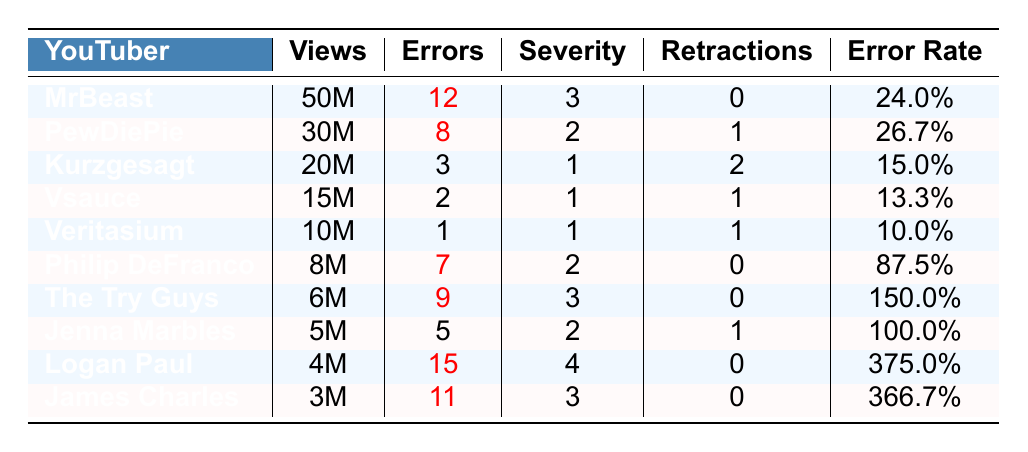What is the highest number of factual errors reported among these YouTubers? In the table, Logan Paul has the highest number of factual errors with 15.
Answer: 15 Which YouTuber has the most retractions issued? PewDiePie has issued 1 retraction, which is the highest among the listed YouTubers since the others have either 0 or 2.
Answer: 1 Calculate the total number of factual errors reported by all YouTubers. The total factual errors are obtained by summing up all values: 12 + 8 + 3 + 2 + 1 + 7 + 9 + 5 + 15 + 11 = 73.
Answer: 73 What is the average number of views per YouTuber in millions? To find the average, add the views (50M + 30M + 20M + 15M + 10M + 8M + 6M + 5M + 4M + 3M = 151M) and divide by the number of YouTubers (10): 151M / 10 = 15.1M.
Answer: 15.1M Is the error rate for The Try Guys higher than that for Philip DeFranco? The Try Guys have an error rate of 150.0%, while Philip DeFranco has an error rate of 87.5%. Since 150.0% is greater than 87.5%, the statement is true.
Answer: Yes Which YouTuber has the lowest error severity score? The lowest error severity score is 1, which belongs to Veritasium, Kurzgesagt, and Vsauce.
Answer: Veritasium, Kurzgesagt, Vsauce What is the total retractions made by YouTubers with factual errors greater than 5? The YouTubers with errors greater than 5 are MrBeast (0), PewDiePie (1), The Try Guys (0), Logan Paul (0), James Charles (0), so total retractions = 0 + 1 + 0 + 0 + 0 = 1.
Answer: 1 If you rank the YouTubers by their error rates, who comes in second place? The YouTubers ranked by error rate from highest to lowest: Logan Paul (375.0%), James Charles (366.7%), The Try Guys (150.0%), PewDiePie (26.7%). So, James Charles takes the second place.
Answer: James Charles What percentage of the total errors comes from MrBeast’s videos? To find this percentage, divide MrBeast's errors (12) by the total errors (73) and multiply by 100: (12 / 73) * 100 ≈ 16.44%.
Answer: 16.44% How many YouTubers reported fewer than 5 factual errors? The YouTubers with fewer than 5 errors are Veritasium (1), Vsauce (2), and Kurzgesagt (3), adding up to 3 YouTubers.
Answer: 3 What is the difference in error rate between Logan Paul and James Charles? Logan Paul has an error rate of 375.0% and James Charles has 366.7%. The difference is 375.0% - 366.7% = 8.3%.
Answer: 8.3% 